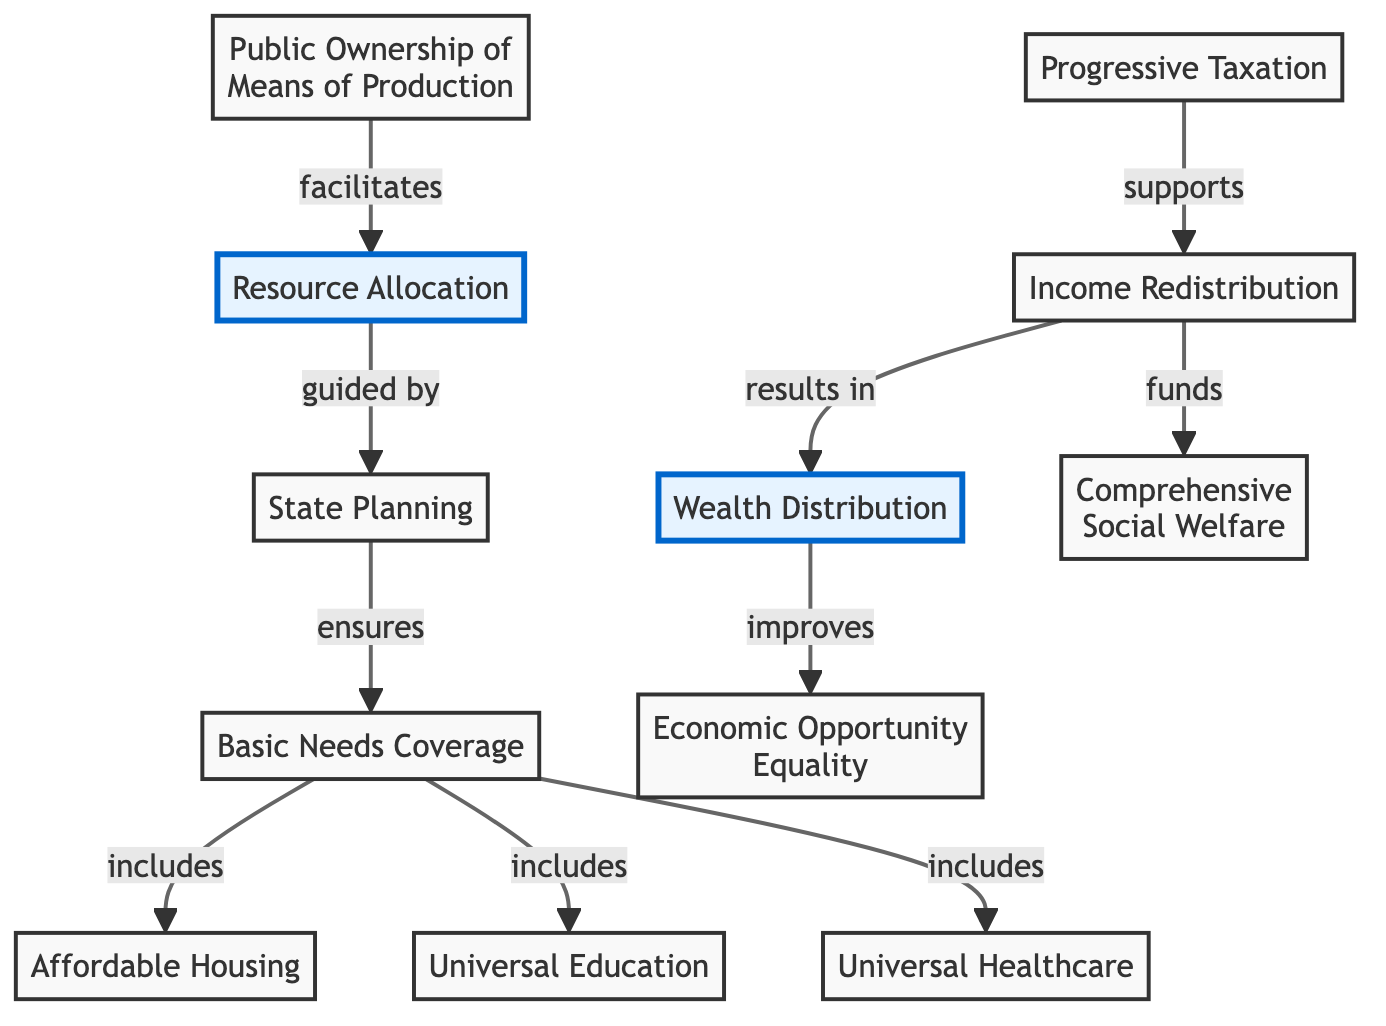What are the two main components of the diagram? The diagram consists of two main components: Wealth Distribution and Resource Allocation. They are the central concepts linked to various supporting elements in the diagram.
Answer: Wealth Distribution, Resource Allocation What supports Income Redistribution? Progressive Taxation supports Income Redistribution by providing the necessary funds and resources to facilitate the redistribution of wealth among the population.
Answer: Progressive Taxation How many basic needs are explicitly mentioned in the diagram? The diagram explicitly mentions three basic needs: Affordable Housing, Universal Education, and Universal Healthcare. These are all included as part of Basic Needs Coverage.
Answer: Three Which node directly results from Income Redistribution? Wealth Distribution results directly from Income Redistribution, as it reflects the outcomes of redistributing income among the populace.
Answer: Wealth Distribution What does State Planning ensure? State Planning ensures Basic Needs Coverage, which encompasses the provision of essential services such as housing, education, and healthcare to all citizens.
Answer: Basic Needs Coverage How does Wealth Distribution improve Economic Opportunity Equality? Wealth Distribution improves Economic Opportunity Equality by aiming to create a more equitable distribution of resources, which helps level the playing field for all individuals in the economy.
Answer: Economic Opportunity Equality How many nodes are there in total, including the main components? There are a total of eleven nodes in the diagram, which includes the two main components and nine additional related concepts that support them.
Answer: Eleven What does Comprehensive Social Welfare fund? Income Redistribution funds Comprehensive Social Welfare, allowing for support systems that aid individuals and families to meet their basic needs.
Answer: Comprehensive Social Welfare Which node is facilitated by Public Ownership of Means of Production? Resource Allocation is facilitated by Public Ownership of Means of Production, reflecting how collective ownership leads to the management of resources for the public good.
Answer: Resource Allocation 